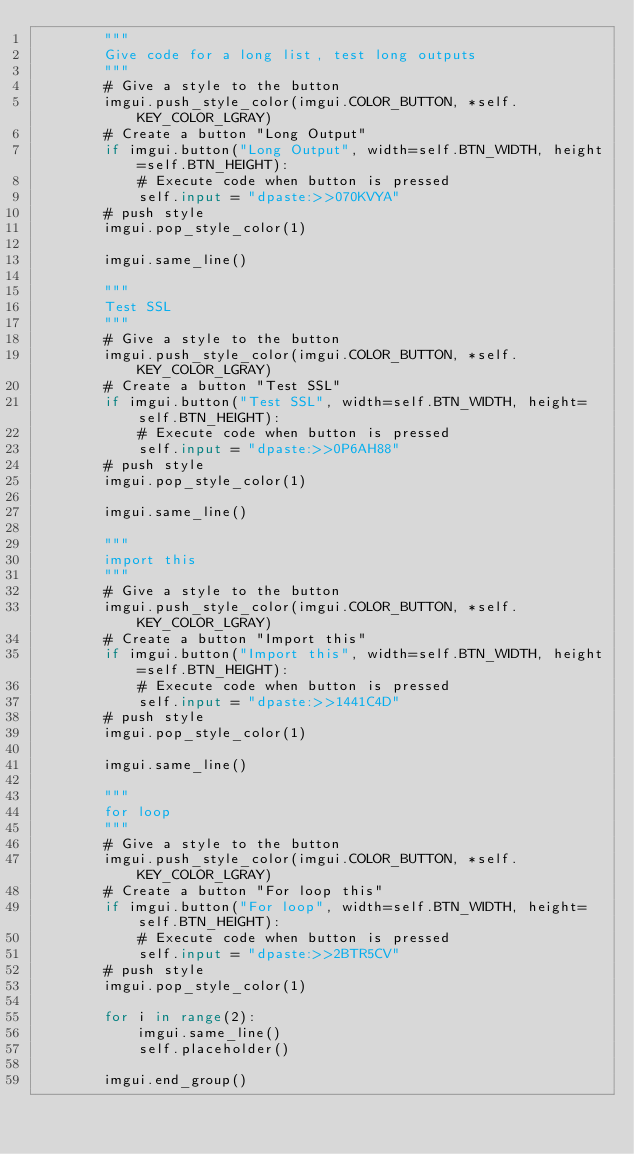<code> <loc_0><loc_0><loc_500><loc_500><_Python_>        """
        Give code for a long list, test long outputs        
        """
        # Give a style to the button
        imgui.push_style_color(imgui.COLOR_BUTTON, *self.KEY_COLOR_LGRAY)
        # Create a button "Long Output"
        if imgui.button("Long Output", width=self.BTN_WIDTH, height=self.BTN_HEIGHT):
            # Execute code when button is pressed
            self.input = "dpaste:>>070KVYA"
        # push style
        imgui.pop_style_color(1)

        imgui.same_line()

        """
        Test SSL
        """
        # Give a style to the button
        imgui.push_style_color(imgui.COLOR_BUTTON, *self.KEY_COLOR_LGRAY)
        # Create a button "Test SSL"
        if imgui.button("Test SSL", width=self.BTN_WIDTH, height=self.BTN_HEIGHT):
            # Execute code when button is pressed
            self.input = "dpaste:>>0P6AH88"
        # push style
        imgui.pop_style_color(1)

        imgui.same_line()

        """
        import this        
        """
        # Give a style to the button
        imgui.push_style_color(imgui.COLOR_BUTTON, *self.KEY_COLOR_LGRAY)
        # Create a button "Import this"
        if imgui.button("Import this", width=self.BTN_WIDTH, height=self.BTN_HEIGHT):
            # Execute code when button is pressed
            self.input = "dpaste:>>1441C4D"
        # push style
        imgui.pop_style_color(1)

        imgui.same_line()

        """
        for loop      
        """
        # Give a style to the button
        imgui.push_style_color(imgui.COLOR_BUTTON, *self.KEY_COLOR_LGRAY)
        # Create a button "For loop this"
        if imgui.button("For loop", width=self.BTN_WIDTH, height=self.BTN_HEIGHT):
            # Execute code when button is pressed
            self.input = "dpaste:>>2BTR5CV"
        # push style
        imgui.pop_style_color(1)

        for i in range(2):
            imgui.same_line()
            self.placeholder()

        imgui.end_group()
</code> 